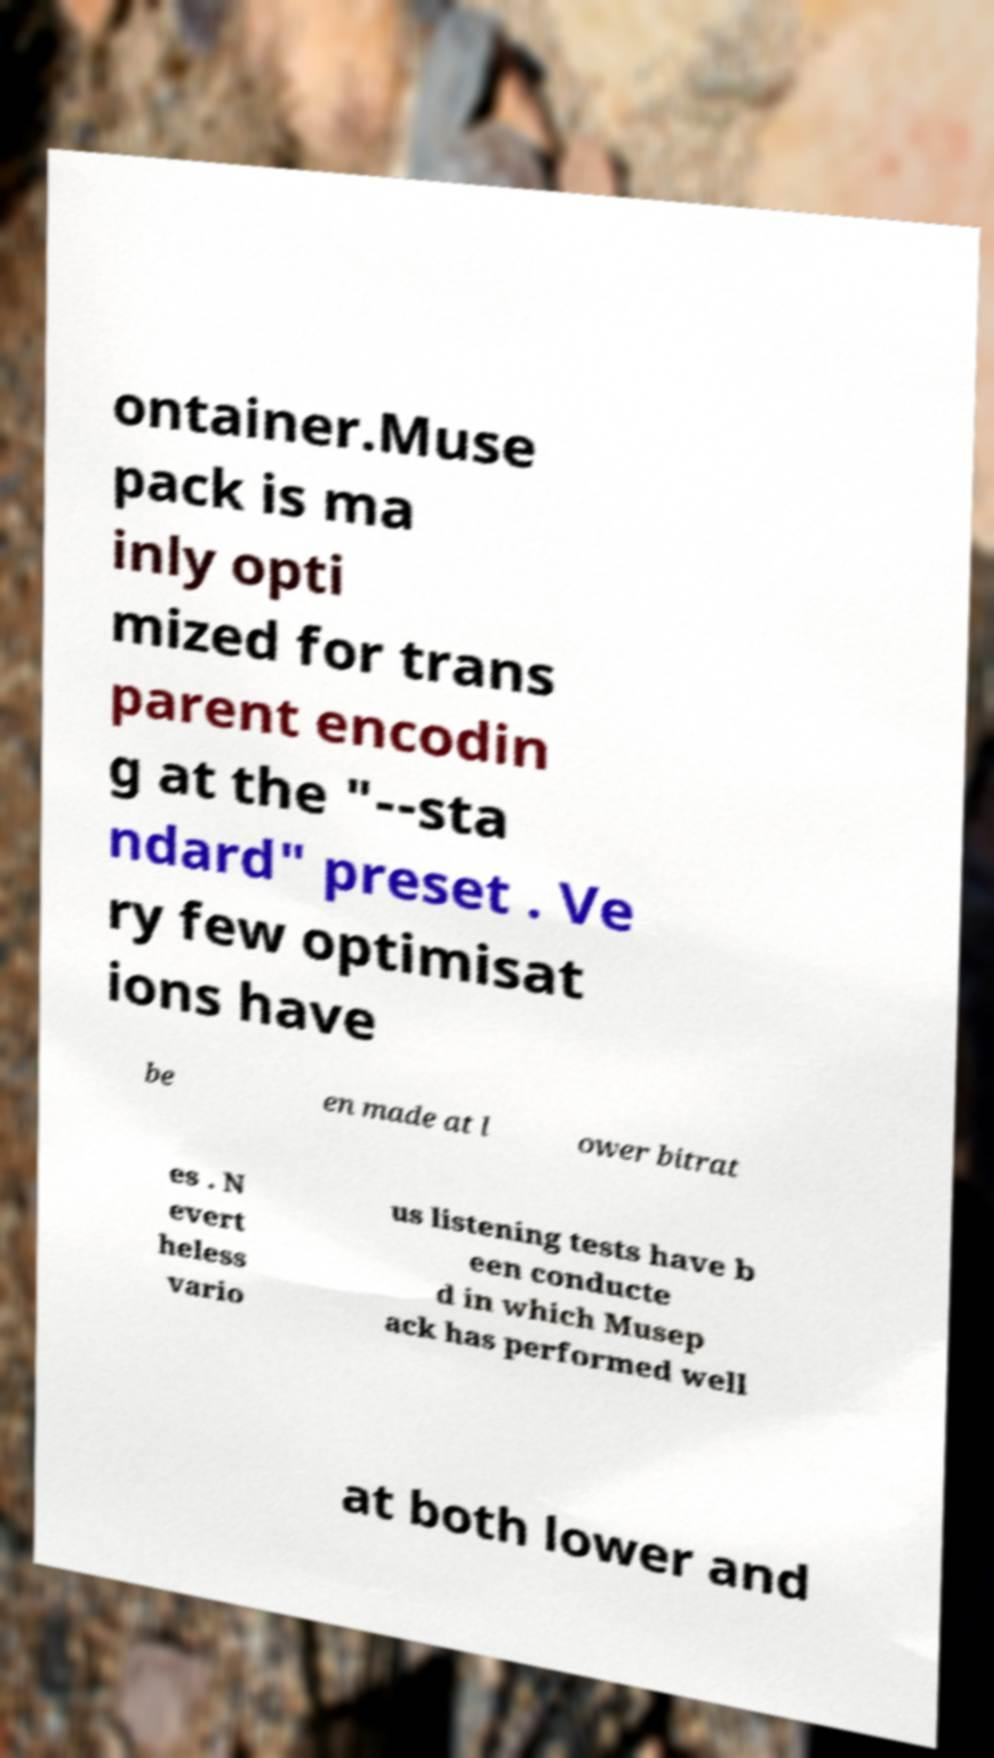Could you assist in decoding the text presented in this image and type it out clearly? ontainer.Muse pack is ma inly opti mized for trans parent encodin g at the "--sta ndard" preset . Ve ry few optimisat ions have be en made at l ower bitrat es . N evert heless vario us listening tests have b een conducte d in which Musep ack has performed well at both lower and 